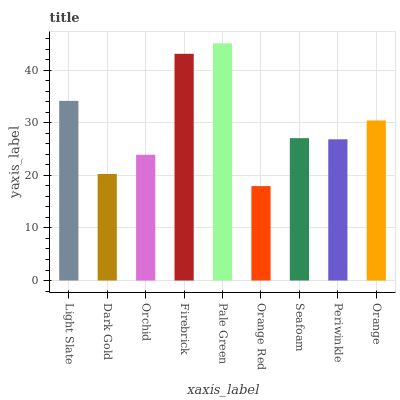Is Dark Gold the minimum?
Answer yes or no. No. Is Dark Gold the maximum?
Answer yes or no. No. Is Light Slate greater than Dark Gold?
Answer yes or no. Yes. Is Dark Gold less than Light Slate?
Answer yes or no. Yes. Is Dark Gold greater than Light Slate?
Answer yes or no. No. Is Light Slate less than Dark Gold?
Answer yes or no. No. Is Seafoam the high median?
Answer yes or no. Yes. Is Seafoam the low median?
Answer yes or no. Yes. Is Firebrick the high median?
Answer yes or no. No. Is Dark Gold the low median?
Answer yes or no. No. 